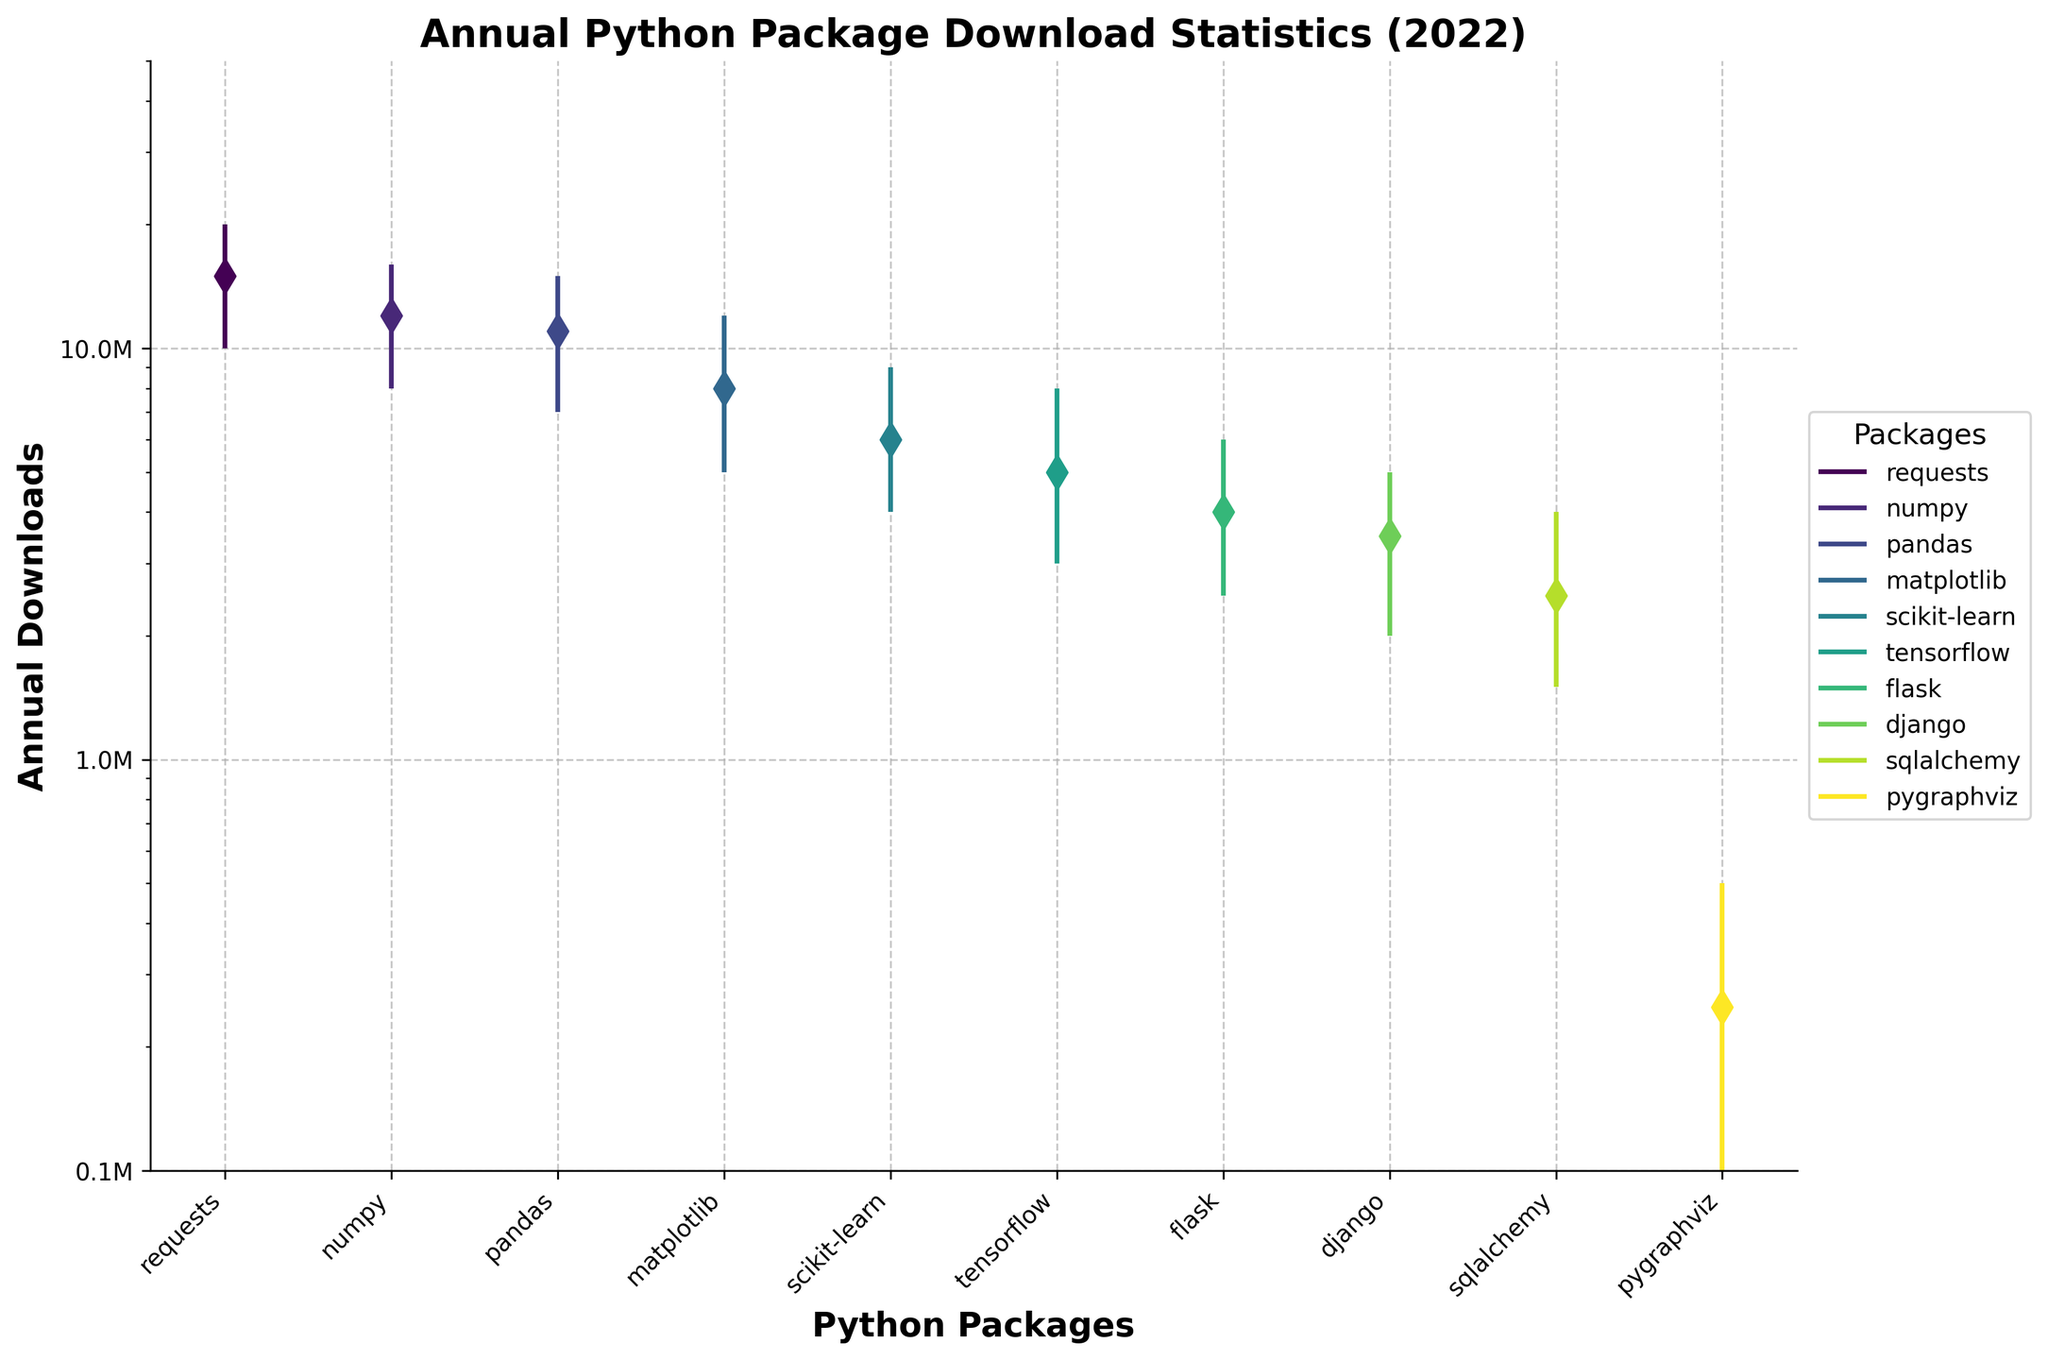What is the title of the figure? The title is prominently displayed at the top of the chart. It reads "Annual Python Package Download Statistics (2022)"
Answer: Annual Python Package Download Statistics (2022) How many Python packages are being analyzed in the figure? The x-axis lists the package names, and by counting them, we find there are 10 packages in total.
Answer: 10 Which Python package had the highest maximum downloads in 2022? By looking at the top of the vertical lines, the "requests" package has the highest point, indicating the maximum downloads.
Answer: requests What is the median annual downloads for the "numpy" package? The median value is marked by a diamond-shaped dot along the vertical line for each package. For "numpy," this dot is at the 12 million mark.
Answer: 12 million Which Python package had the lowest minimum downloads in 2022? By identifying the lowest point on the vertical lines, "pygraphviz" is the package with the lowest minimum downloads.
Answer: pygraphviz By how much do the maximum downloads of "requests" exceed those of "flask"? The maximum downloads for "requests" are 20 million, and for "flask" it is 6 million. The difference is 20 million - 6 million.
Answer: 14 million Which two Python packages have median download counts closest to each other? The median downloads are identified by the diamond-shaped dots. "django" and "sqlalchemy" have closely positioned median dots, with counts of 3.5 million and 2.5 million respectively.
Answer: django and sqlalchemy What is the range of annual downloads for "matplotlib" package? The range is calculated by subtracting the minimum value from the maximum value. For "matplotlib," this is 12 million - 5 million.
Answer: 7 million List all Python packages with a median download count below 5 million. The median downloads below 5 million can be identified by the diamond-shaped dots below this threshold: "scikit-learn," "tensorflow," "flask," "django," "sqlalchemy," and "pygraphviz."
Answer: scikit-learn, tensorflow, flask, django, sqlalchemy, pygraphviz Between "pandas" and "matplotlib," which had a higher minimum download count in 2022? The minimum value is the lowest point on the vertical lines. Comparing "pandas" (7 million) and "matplotlib" (5 million), "pandas" has a higher minimum download count.
Answer: pandas 